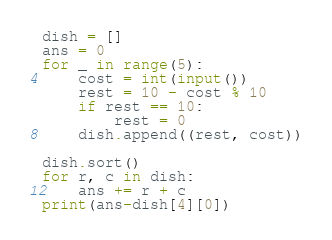Convert code to text. <code><loc_0><loc_0><loc_500><loc_500><_Python_>dish = []
ans = 0
for _ in range(5):
    cost = int(input())
    rest = 10 - cost % 10
    if rest == 10:
        rest = 0
    dish.append((rest, cost))

dish.sort()
for r, c in dish:
    ans += r + c
print(ans-dish[4][0])
</code> 